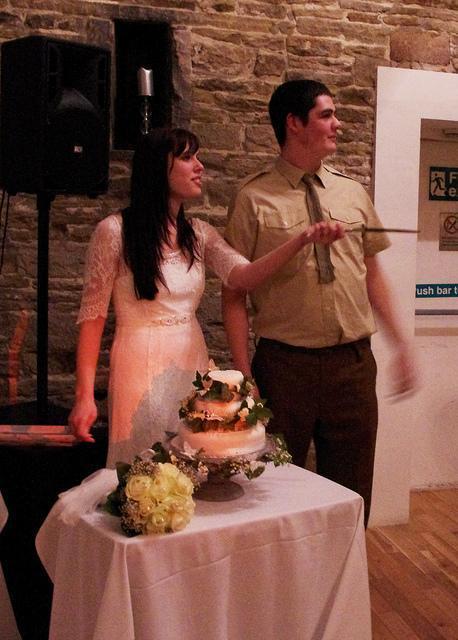Is this affirmation: "The cake is in the middle of the dining table." correct?
Answer yes or no. Yes. 